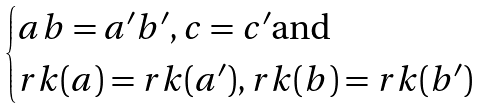Convert formula to latex. <formula><loc_0><loc_0><loc_500><loc_500>\begin{cases} a b = a ^ { \prime } b ^ { \prime } , c = c ^ { \prime } \text {and} \\ r k ( a ) = r k ( a ^ { \prime } ) , r k ( b ) = r k ( b ^ { \prime } ) \end{cases}</formula> 